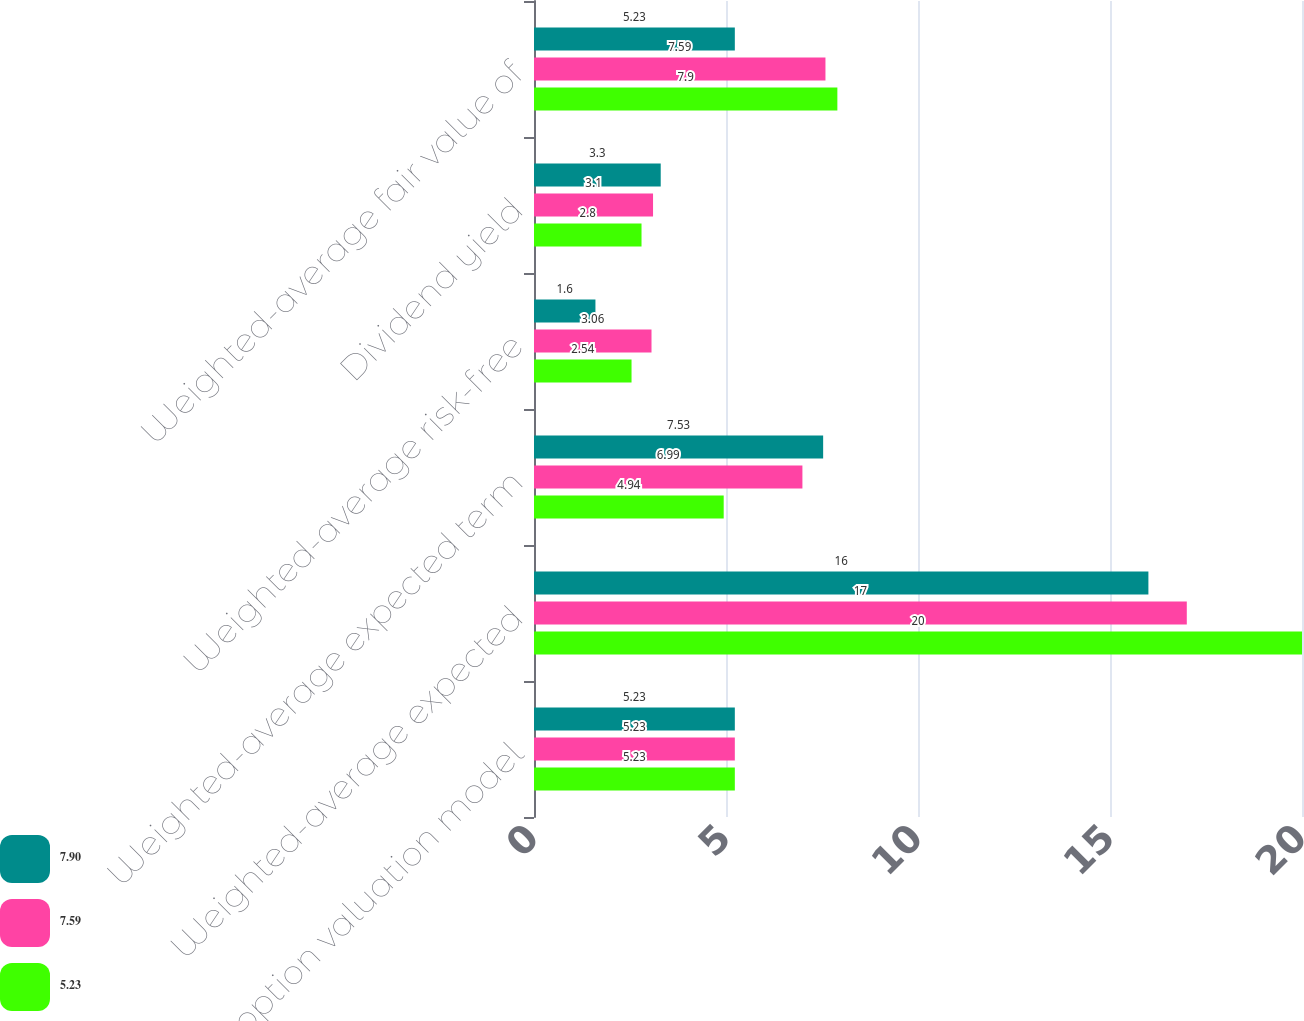Convert chart to OTSL. <chart><loc_0><loc_0><loc_500><loc_500><stacked_bar_chart><ecel><fcel>Stock option valuation model<fcel>Weighted-average expected<fcel>Weighted-average expected term<fcel>Weighted-average risk-free<fcel>Dividend yield<fcel>Weighted-average fair value of<nl><fcel>7.9<fcel>5.23<fcel>16<fcel>7.53<fcel>1.6<fcel>3.3<fcel>5.23<nl><fcel>7.59<fcel>5.23<fcel>17<fcel>6.99<fcel>3.06<fcel>3.1<fcel>7.59<nl><fcel>5.23<fcel>5.23<fcel>20<fcel>4.94<fcel>2.54<fcel>2.8<fcel>7.9<nl></chart> 